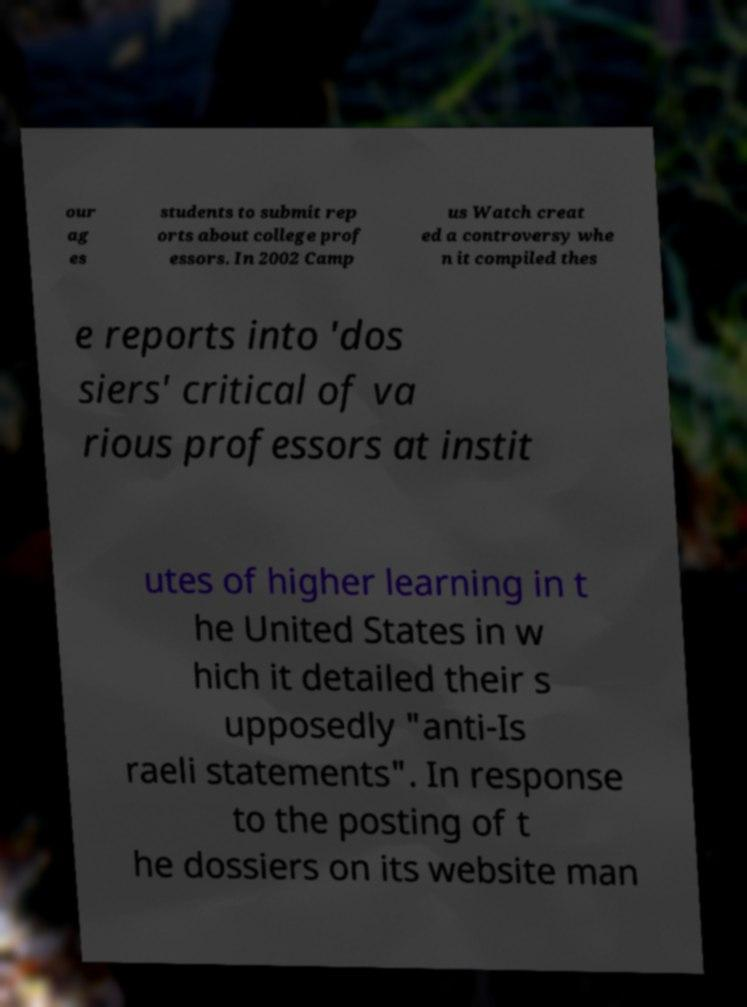Please identify and transcribe the text found in this image. our ag es students to submit rep orts about college prof essors. In 2002 Camp us Watch creat ed a controversy whe n it compiled thes e reports into 'dos siers' critical of va rious professors at instit utes of higher learning in t he United States in w hich it detailed their s upposedly "anti-Is raeli statements". In response to the posting of t he dossiers on its website man 